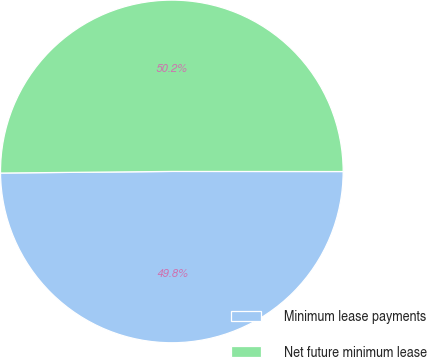Convert chart to OTSL. <chart><loc_0><loc_0><loc_500><loc_500><pie_chart><fcel>Minimum lease payments<fcel>Net future minimum lease<nl><fcel>49.84%<fcel>50.16%<nl></chart> 